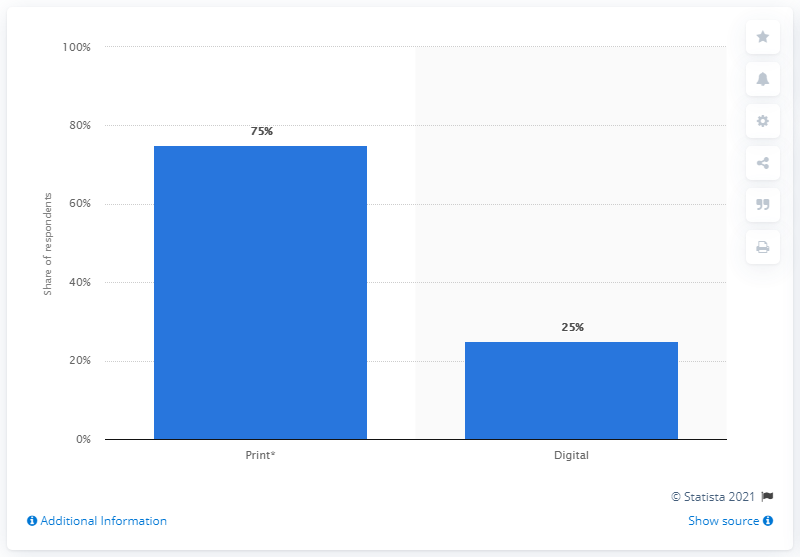Identify some key points in this picture. According to a survey of comic book readers, 75% prefer reading comic books in print. 